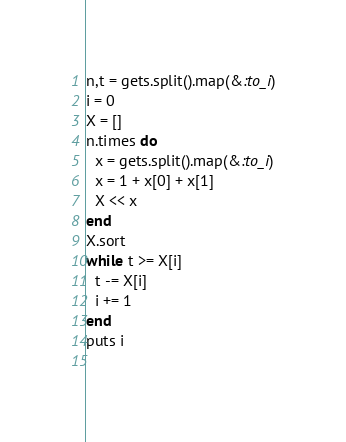<code> <loc_0><loc_0><loc_500><loc_500><_Ruby_>n,t = gets.split().map(&:to_i)
i = 0
X = []
n.times do
  x = gets.split().map(&:to_i)
  x = 1 + x[0] + x[1]
  X << x
end
X.sort
while t >= X[i]
  t -= X[i]
  i += 1
end
puts i
  </code> 